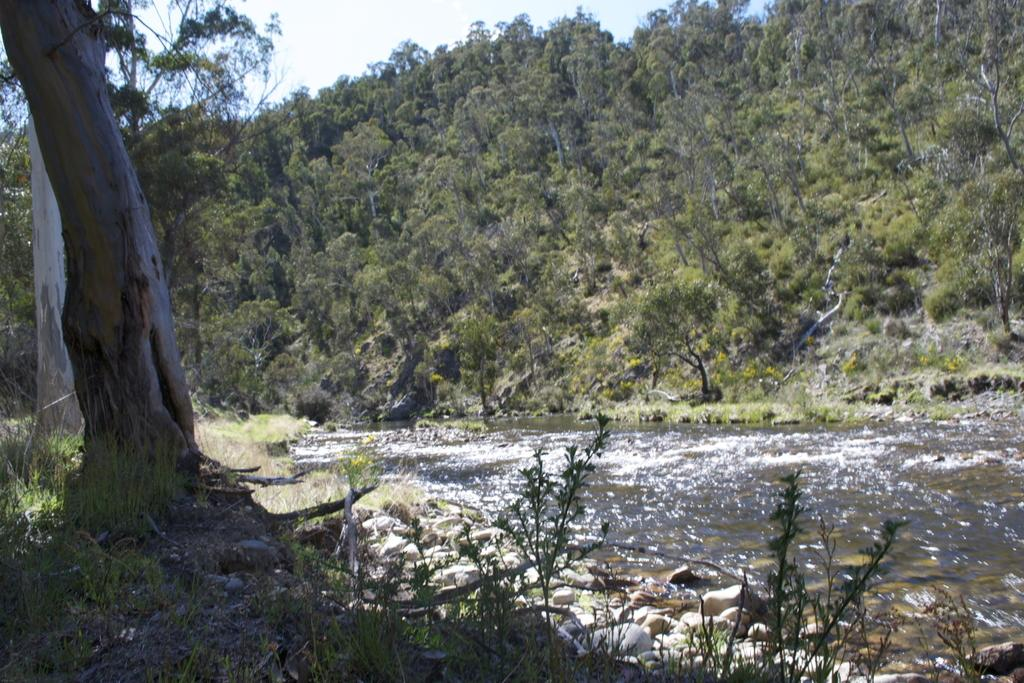What type of vegetation is on the left side of the image? There are trees on the ground on the left side of the image. What type of objects can be seen in the image? There are stones and plants visible in the image. What is the nature of the water in the image? The water is visible in the image. What can be seen in the background of the image? There are trees and the sky visible in the background of the image. What type of boot is hanging from the tree in the image? There is no boot present in the image; it features trees, stones, plants, water, and the sky. What type of border can be seen around the image? The image does not have a border; it is a photograph or digital representation of a scene. 